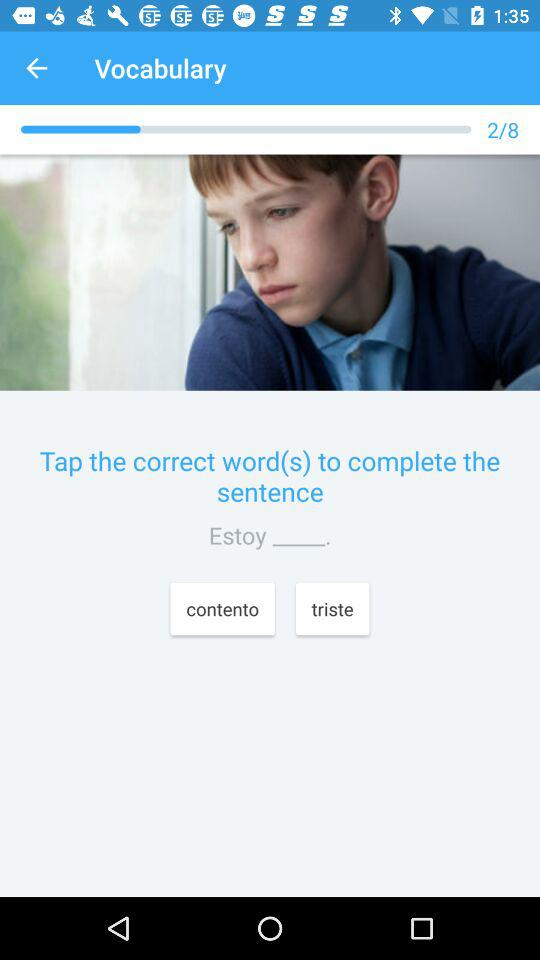What is the current question? The current question is 2. 